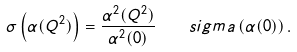Convert formula to latex. <formula><loc_0><loc_0><loc_500><loc_500>\sigma \left ( \alpha ( Q ^ { 2 } ) \right ) = \frac { \alpha ^ { 2 } ( Q ^ { 2 } ) } { \alpha ^ { 2 } ( 0 ) } \quad s i g m a \left ( \alpha ( 0 ) \right ) .</formula> 